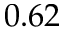<formula> <loc_0><loc_0><loc_500><loc_500>0 . 6 2</formula> 